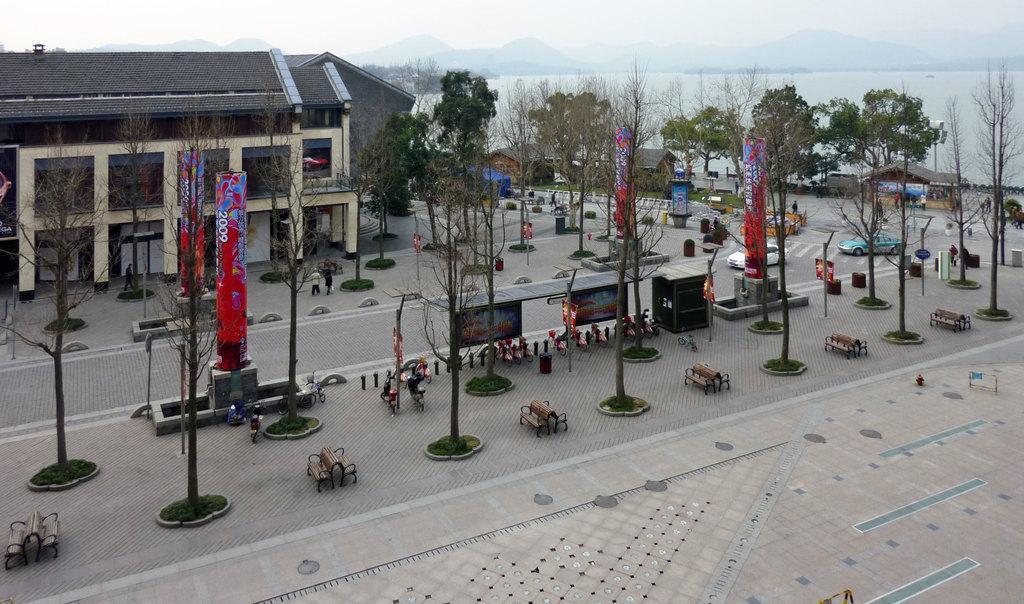Can you describe this image briefly? In this image I can see a lane with trees,benches,cars and some objects. Also there are people, a building, and in the background there is a sky,water and mountains. 